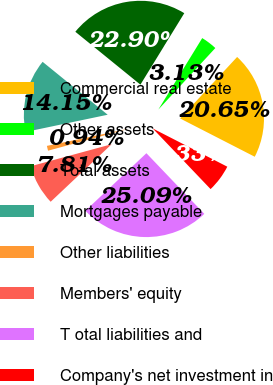Convert chart. <chart><loc_0><loc_0><loc_500><loc_500><pie_chart><fcel>Commercial real estate<fcel>Other assets<fcel>Total assets<fcel>Mortgages payable<fcel>Other liabilities<fcel>Members' equity<fcel>T otal liabilities and<fcel>Company's net investment in<nl><fcel>20.65%<fcel>3.13%<fcel>22.9%<fcel>14.15%<fcel>0.94%<fcel>7.81%<fcel>25.09%<fcel>5.33%<nl></chart> 